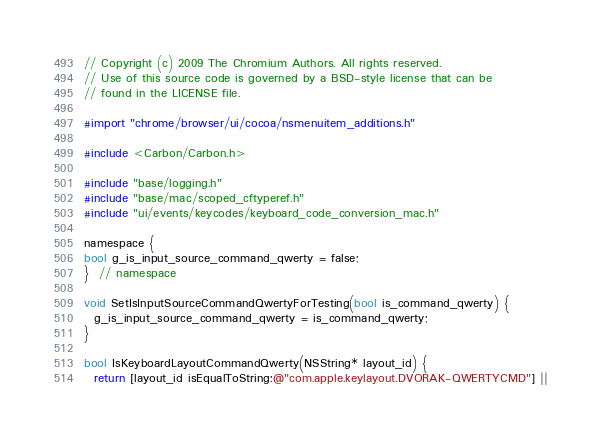<code> <loc_0><loc_0><loc_500><loc_500><_ObjectiveC_>// Copyright (c) 2009 The Chromium Authors. All rights reserved.
// Use of this source code is governed by a BSD-style license that can be
// found in the LICENSE file.

#import "chrome/browser/ui/cocoa/nsmenuitem_additions.h"

#include <Carbon/Carbon.h>

#include "base/logging.h"
#include "base/mac/scoped_cftyperef.h"
#include "ui/events/keycodes/keyboard_code_conversion_mac.h"

namespace {
bool g_is_input_source_command_qwerty = false;
}  // namespace

void SetIsInputSourceCommandQwertyForTesting(bool is_command_qwerty) {
  g_is_input_source_command_qwerty = is_command_qwerty;
}

bool IsKeyboardLayoutCommandQwerty(NSString* layout_id) {
  return [layout_id isEqualToString:@"com.apple.keylayout.DVORAK-QWERTYCMD"] ||</code> 